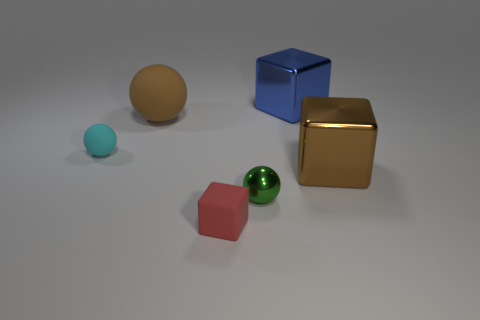The metallic thing that is both on the left side of the big brown metallic thing and in front of the big brown rubber sphere has what shape?
Provide a short and direct response. Sphere. Are there any big objects of the same color as the large ball?
Provide a succinct answer. Yes. There is a thing that is both in front of the large brown rubber ball and right of the green shiny ball; what is its size?
Your response must be concise. Large. The rubber object that is behind the cyan matte object has what shape?
Provide a succinct answer. Sphere. What material is the small green thing that is the same shape as the large rubber thing?
Provide a succinct answer. Metal. The small rubber thing that is behind the thing that is right of the blue metal block is what shape?
Offer a terse response. Sphere. Is the brown object left of the red matte thing made of the same material as the blue block?
Offer a very short reply. No. Are there an equal number of cyan things in front of the small metallic thing and blue cubes behind the matte cube?
Provide a succinct answer. No. How many brown metal blocks are behind the block that is to the left of the tiny green metal thing?
Give a very brief answer. 1. Do the large thing that is to the left of the small red thing and the large shiny cube that is in front of the big rubber object have the same color?
Your answer should be compact. Yes. 